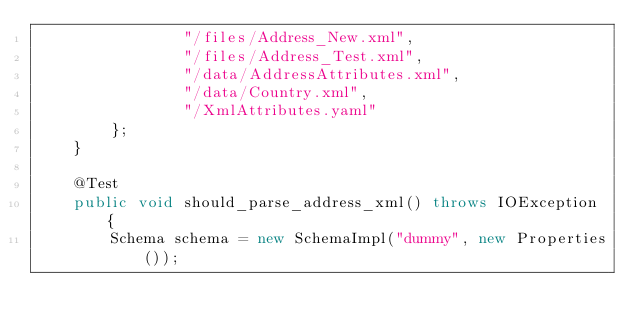<code> <loc_0><loc_0><loc_500><loc_500><_Java_>                "/files/Address_New.xml",
                "/files/Address_Test.xml",
                "/data/AddressAttributes.xml",
                "/data/Country.xml",
                "/XmlAttributes.yaml"
        };
    }

    @Test
    public void should_parse_address_xml() throws IOException {
        Schema schema = new SchemaImpl("dummy", new Properties());</code> 